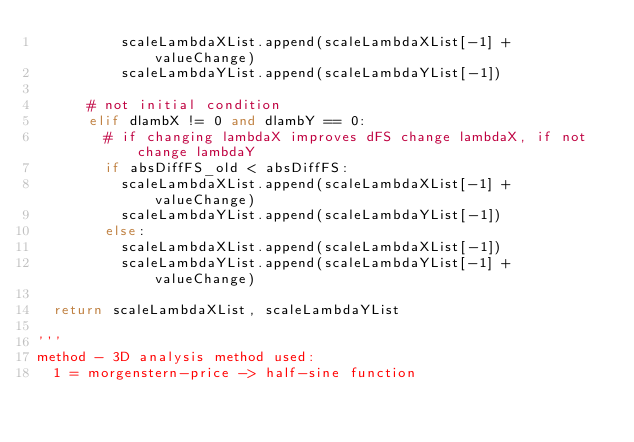<code> <loc_0><loc_0><loc_500><loc_500><_Python_>					scaleLambdaXList.append(scaleLambdaXList[-1] + valueChange)
					scaleLambdaYList.append(scaleLambdaYList[-1])
			
			# not initial condition
			elif dlambX != 0 and dlambY == 0:
				# if changing lambdaX improves dFS change lambdaX, if not change lambdaY
				if absDiffFS_old < absDiffFS:
					scaleLambdaXList.append(scaleLambdaXList[-1] + valueChange)
					scaleLambdaYList.append(scaleLambdaYList[-1])
				else:
					scaleLambdaXList.append(scaleLambdaXList[-1])
					scaleLambdaYList.append(scaleLambdaYList[-1] + valueChange)

	return scaleLambdaXList, scaleLambdaYList

'''
method - 3D analysis method used:
	1 = morgenstern-price -> half-sine function</code> 